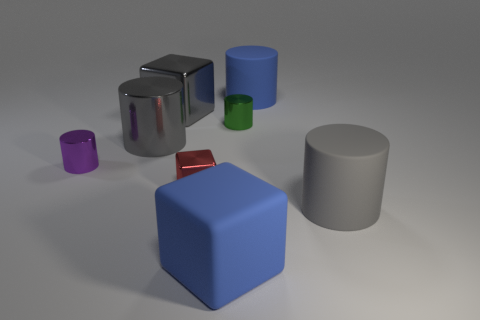There is a metal cube that is the same size as the green metallic object; what color is it?
Your response must be concise. Red. There is a red object; is its shape the same as the metallic object on the right side of the matte cube?
Ensure brevity in your answer.  No. What is the shape of the rubber object that is the same color as the matte cube?
Your answer should be compact. Cylinder. There is a tiny cylinder left of the blue object that is in front of the blue matte cylinder; how many blue blocks are in front of it?
Your answer should be compact. 1. What size is the blue object behind the matte cylinder in front of the purple cylinder?
Your answer should be compact. Large. What size is the gray cylinder that is the same material as the small red block?
Offer a very short reply. Large. The big object that is behind the purple object and on the right side of the red metallic cube has what shape?
Keep it short and to the point. Cylinder. Is the number of large gray metal things that are to the right of the large blue matte cylinder the same as the number of gray matte spheres?
Your answer should be compact. Yes. What number of objects are either tiny gray metallic blocks or shiny things that are behind the red metal object?
Your answer should be compact. 4. Is there another metal object of the same shape as the tiny purple object?
Make the answer very short. Yes. 